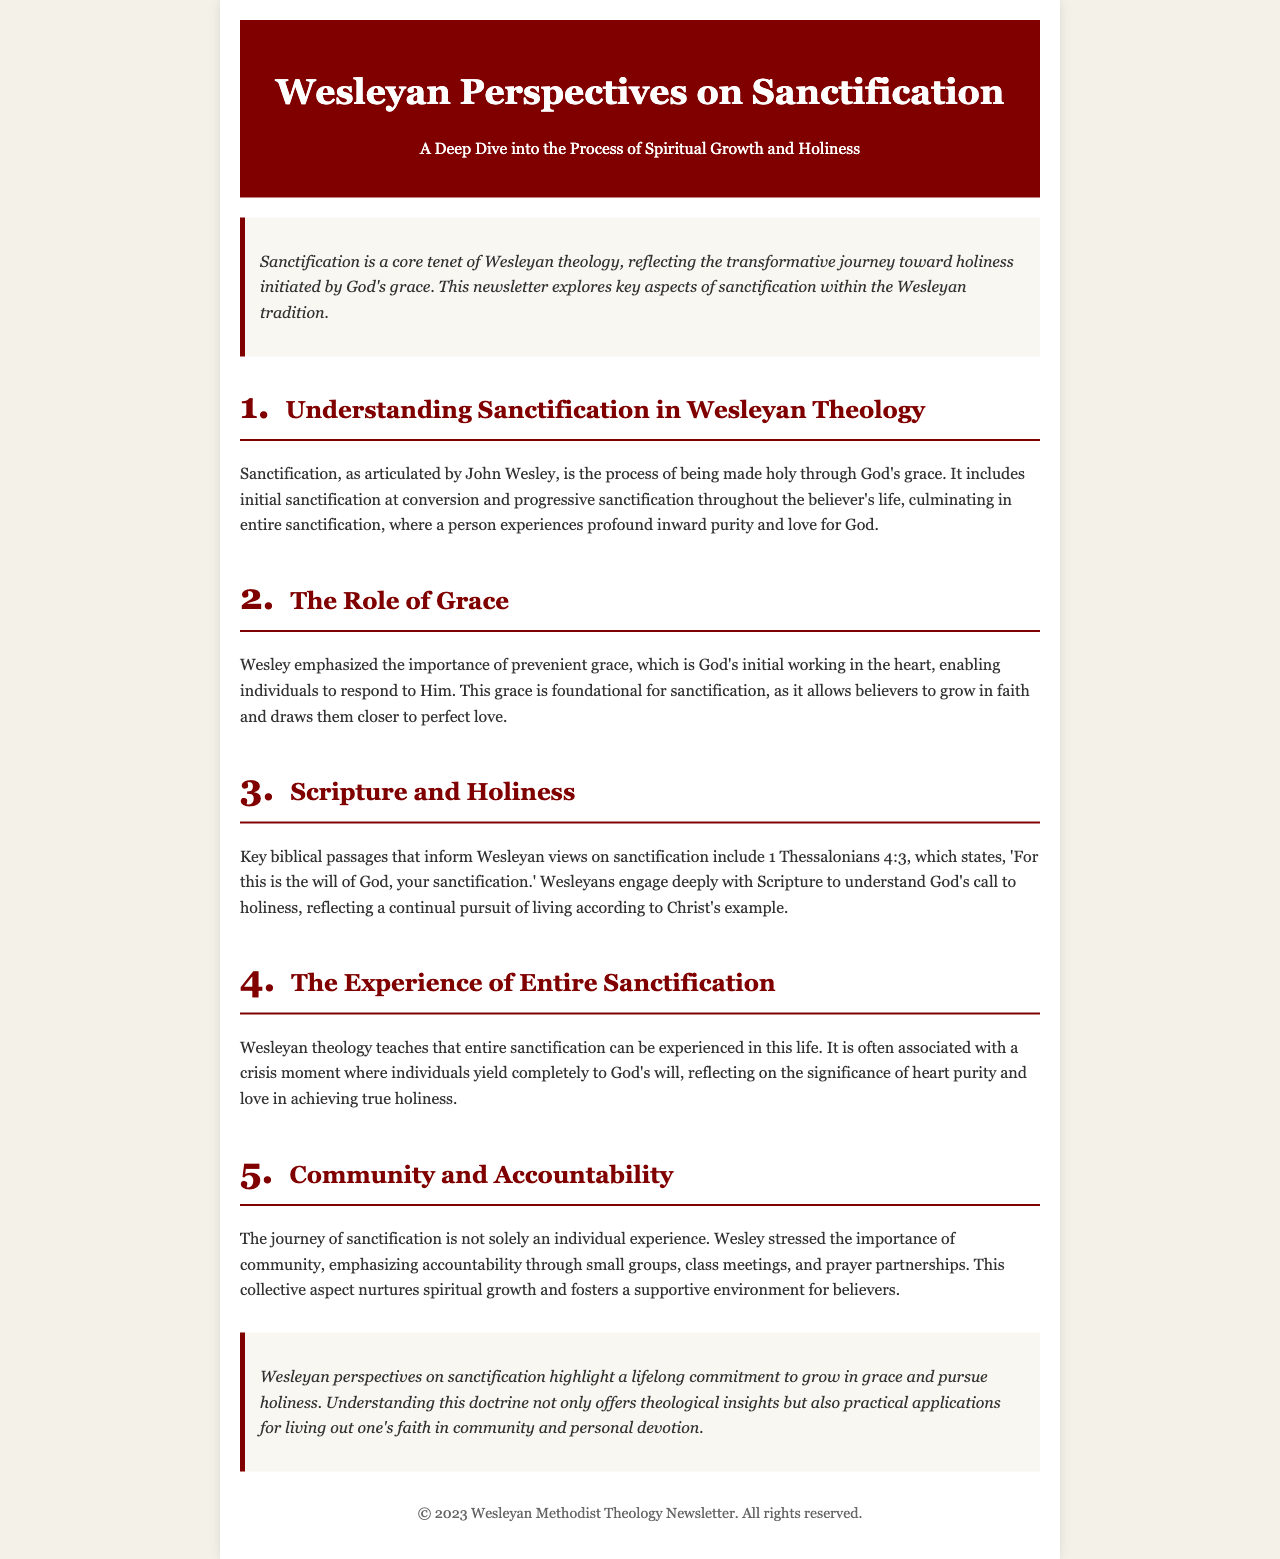what is the title of the newsletter? The title of the newsletter is prominently displayed in the header section.
Answer: Wesleyan Perspectives on Sanctification what is the main theme of the newsletter? The theme is summarized in the subtitle under the title, indicating the focus of the content.
Answer: A Deep Dive into the Process of Spiritual Growth and Holiness who articulated the concept of sanctification in Wesleyan theology? The document explicitly identifies who is associated with the teaching on sanctification within the tradition.
Answer: John Wesley which biblical passage is cited regarding God's will for sanctification? The newsletter refers to a specific scripture passage that emphasizes God's intentions for believers.
Answer: 1 Thessalonians 4:3 what does Wesley emphasize as foundational for sanctification? The text discusses key elements that are critical for the process of becoming holy according to Wesleyan beliefs.
Answer: Prevenient grace how does the document describe the experience of entire sanctification? The newsletter details a significant moment related to the process of sanctification that believers may experience.
Answer: Crisis moment what role does community play in the journey of sanctification, according to the newsletter? The document highlights an important aspect of spiritual growth that involves interpersonal relationships among believers.
Answer: Accountability what is the final takeaway regarding Wesleyan perspectives on sanctification? The conclusion summarizes the overarching message of the newsletter about sanctification and its practical implications.
Answer: Lifelong commitment to grow in grace and pursue holiness 